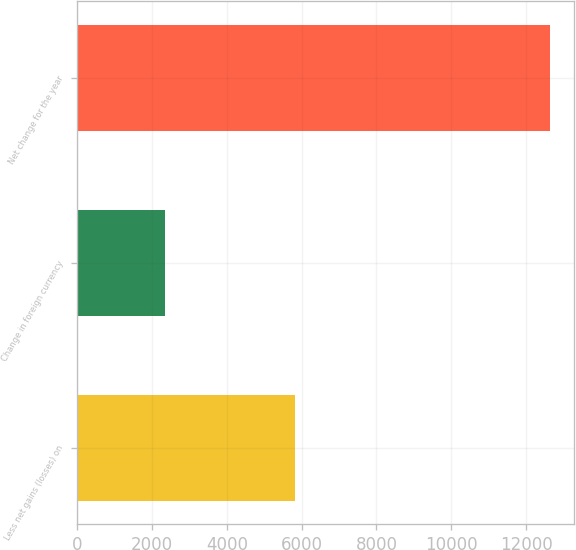<chart> <loc_0><loc_0><loc_500><loc_500><bar_chart><fcel>Less net gains (losses) on<fcel>Change in foreign currency<fcel>Net change for the year<nl><fcel>5811<fcel>2348<fcel>12638<nl></chart> 